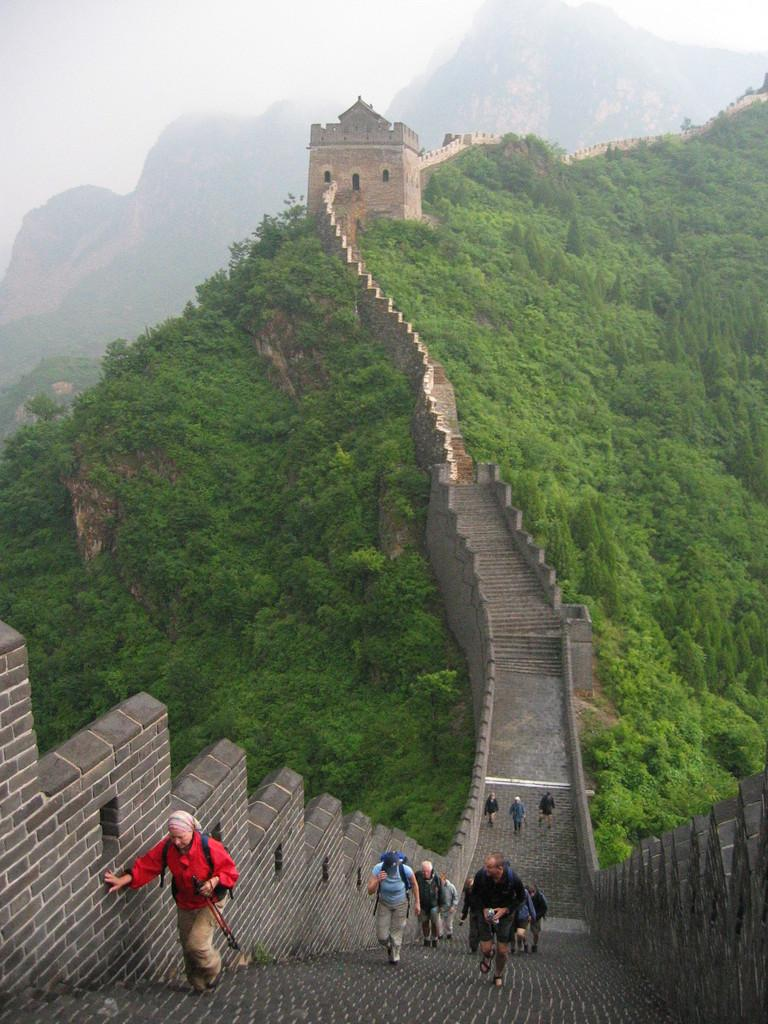Who or what can be seen in the image? There are people in the image. What type of structures are present in the image? There are walls and a fort in the image. Are there any architectural features in the image? Yes, there are steps in the image. What type of natural environment is visible in the image? There are trees and hills visible in the image. What part of the natural environment is visible in the background of the image? The sky is visible in the background of the image. What type of wax is being used by the team in the image? There is no wax or team present in the image. What type of flight can be seen in the image? There is no flight visible in the image. 